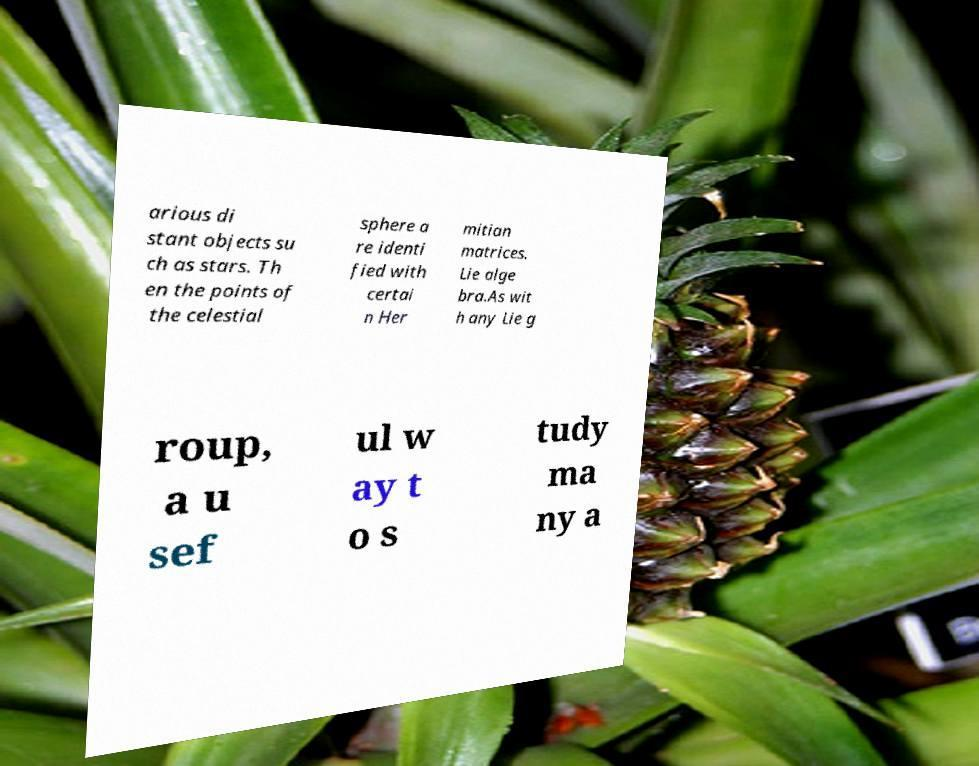Please identify and transcribe the text found in this image. arious di stant objects su ch as stars. Th en the points of the celestial sphere a re identi fied with certai n Her mitian matrices. Lie alge bra.As wit h any Lie g roup, a u sef ul w ay t o s tudy ma ny a 